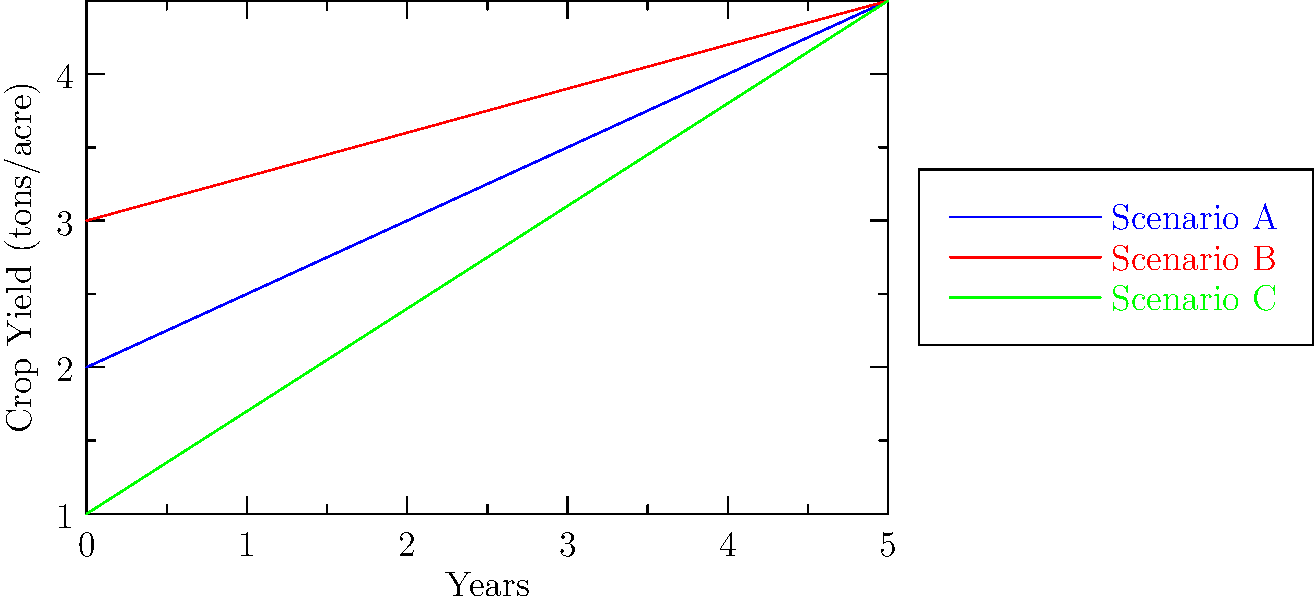Based on the line graph showing crop yield projections for three different climate scenarios over the next 5 years, which scenario is likely to result in the highest crop yield by the end of the 5-year period? To determine which scenario will result in the highest crop yield by the end of the 5-year period, we need to compare the positions of the three lines at the 5-year mark:

1. Identify the three scenarios:
   - Scenario A: Blue line
   - Scenario B: Red line
   - Scenario C: Green line

2. Observe the slope (rate of increase) for each line:
   - Scenario A: Moderate slope
   - Scenario B: Lowest slope
   - Scenario C: Steepest slope

3. Compare the positions of the lines at the 5-year mark:
   - Scenario A: Approximately 4.5 tons/acre
   - Scenario B: Approximately 4.5 tons/acre
   - Scenario C: Approximately 4.5 tons/acre

4. Determine which line is highest at the 5-year mark:
   Scenario C (green line) is slightly higher than the other two at the 5-year point.

Therefore, Scenario C is likely to result in the highest crop yield by the end of the 5-year period.
Answer: Scenario C 